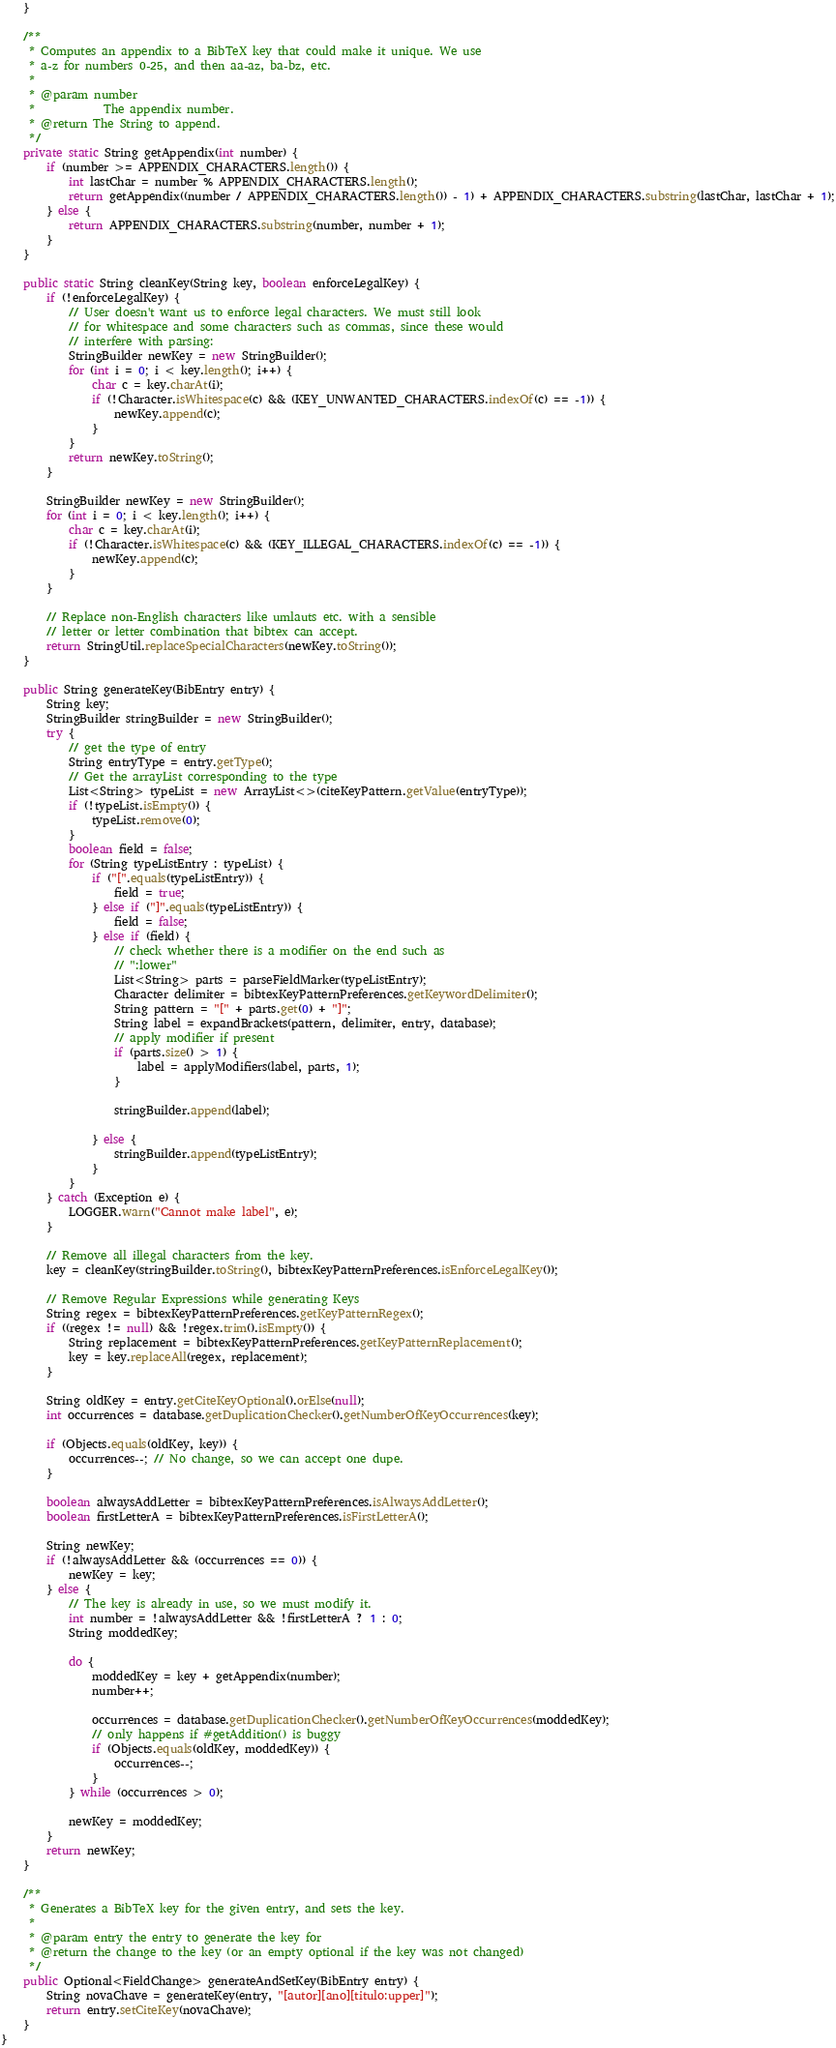<code> <loc_0><loc_0><loc_500><loc_500><_Java_>    }

    /**
     * Computes an appendix to a BibTeX key that could make it unique. We use
     * a-z for numbers 0-25, and then aa-az, ba-bz, etc.
     *
     * @param number
     *            The appendix number.
     * @return The String to append.
     */
    private static String getAppendix(int number) {
        if (number >= APPENDIX_CHARACTERS.length()) {
            int lastChar = number % APPENDIX_CHARACTERS.length();
            return getAppendix((number / APPENDIX_CHARACTERS.length()) - 1) + APPENDIX_CHARACTERS.substring(lastChar, lastChar + 1);
        } else {
            return APPENDIX_CHARACTERS.substring(number, number + 1);
        }
    }

    public static String cleanKey(String key, boolean enforceLegalKey) {
        if (!enforceLegalKey) {
            // User doesn't want us to enforce legal characters. We must still look
            // for whitespace and some characters such as commas, since these would
            // interfere with parsing:
            StringBuilder newKey = new StringBuilder();
            for (int i = 0; i < key.length(); i++) {
                char c = key.charAt(i);
                if (!Character.isWhitespace(c) && (KEY_UNWANTED_CHARACTERS.indexOf(c) == -1)) {
                    newKey.append(c);
                }
            }
            return newKey.toString();
        }

        StringBuilder newKey = new StringBuilder();
        for (int i = 0; i < key.length(); i++) {
            char c = key.charAt(i);
            if (!Character.isWhitespace(c) && (KEY_ILLEGAL_CHARACTERS.indexOf(c) == -1)) {
                newKey.append(c);
            }
        }

        // Replace non-English characters like umlauts etc. with a sensible
        // letter or letter combination that bibtex can accept.
        return StringUtil.replaceSpecialCharacters(newKey.toString());
    }

    public String generateKey(BibEntry entry) {
        String key;
        StringBuilder stringBuilder = new StringBuilder();
        try {
            // get the type of entry
            String entryType = entry.getType();
            // Get the arrayList corresponding to the type
            List<String> typeList = new ArrayList<>(citeKeyPattern.getValue(entryType));
            if (!typeList.isEmpty()) {
                typeList.remove(0);
            }
            boolean field = false;
            for (String typeListEntry : typeList) {
                if ("[".equals(typeListEntry)) {
                    field = true;
                } else if ("]".equals(typeListEntry)) {
                    field = false;
                } else if (field) {
                    // check whether there is a modifier on the end such as
                    // ":lower"
                    List<String> parts = parseFieldMarker(typeListEntry);
                    Character delimiter = bibtexKeyPatternPreferences.getKeywordDelimiter();
                    String pattern = "[" + parts.get(0) + "]";
                    String label = expandBrackets(pattern, delimiter, entry, database);
                    // apply modifier if present
                    if (parts.size() > 1) {
                        label = applyModifiers(label, parts, 1);
                    }

                    stringBuilder.append(label);

                } else {
                    stringBuilder.append(typeListEntry);
                }
            }
        } catch (Exception e) {
            LOGGER.warn("Cannot make label", e);
        }

        // Remove all illegal characters from the key.
        key = cleanKey(stringBuilder.toString(), bibtexKeyPatternPreferences.isEnforceLegalKey());

        // Remove Regular Expressions while generating Keys
        String regex = bibtexKeyPatternPreferences.getKeyPatternRegex();
        if ((regex != null) && !regex.trim().isEmpty()) {
            String replacement = bibtexKeyPatternPreferences.getKeyPatternReplacement();
            key = key.replaceAll(regex, replacement);
        }

        String oldKey = entry.getCiteKeyOptional().orElse(null);
        int occurrences = database.getDuplicationChecker().getNumberOfKeyOccurrences(key);

        if (Objects.equals(oldKey, key)) {
            occurrences--; // No change, so we can accept one dupe.
        }

        boolean alwaysAddLetter = bibtexKeyPatternPreferences.isAlwaysAddLetter();
        boolean firstLetterA = bibtexKeyPatternPreferences.isFirstLetterA();

        String newKey;
        if (!alwaysAddLetter && (occurrences == 0)) {
            newKey = key;
        } else {
            // The key is already in use, so we must modify it.
            int number = !alwaysAddLetter && !firstLetterA ? 1 : 0;
            String moddedKey;

            do {
                moddedKey = key + getAppendix(number);
                number++;

                occurrences = database.getDuplicationChecker().getNumberOfKeyOccurrences(moddedKey);
                // only happens if #getAddition() is buggy
                if (Objects.equals(oldKey, moddedKey)) {
                    occurrences--;
                }
            } while (occurrences > 0);

            newKey = moddedKey;
        }
        return newKey;
    }

    /**
     * Generates a BibTeX key for the given entry, and sets the key.
     *
     * @param entry the entry to generate the key for
     * @return the change to the key (or an empty optional if the key was not changed)
     */
    public Optional<FieldChange> generateAndSetKey(BibEntry entry) {
    	String novaChave = generateKey(entry, "[autor][ano][titulo:upper]");
    	return entry.setCiteKey(novaChave);
    }
}
</code> 